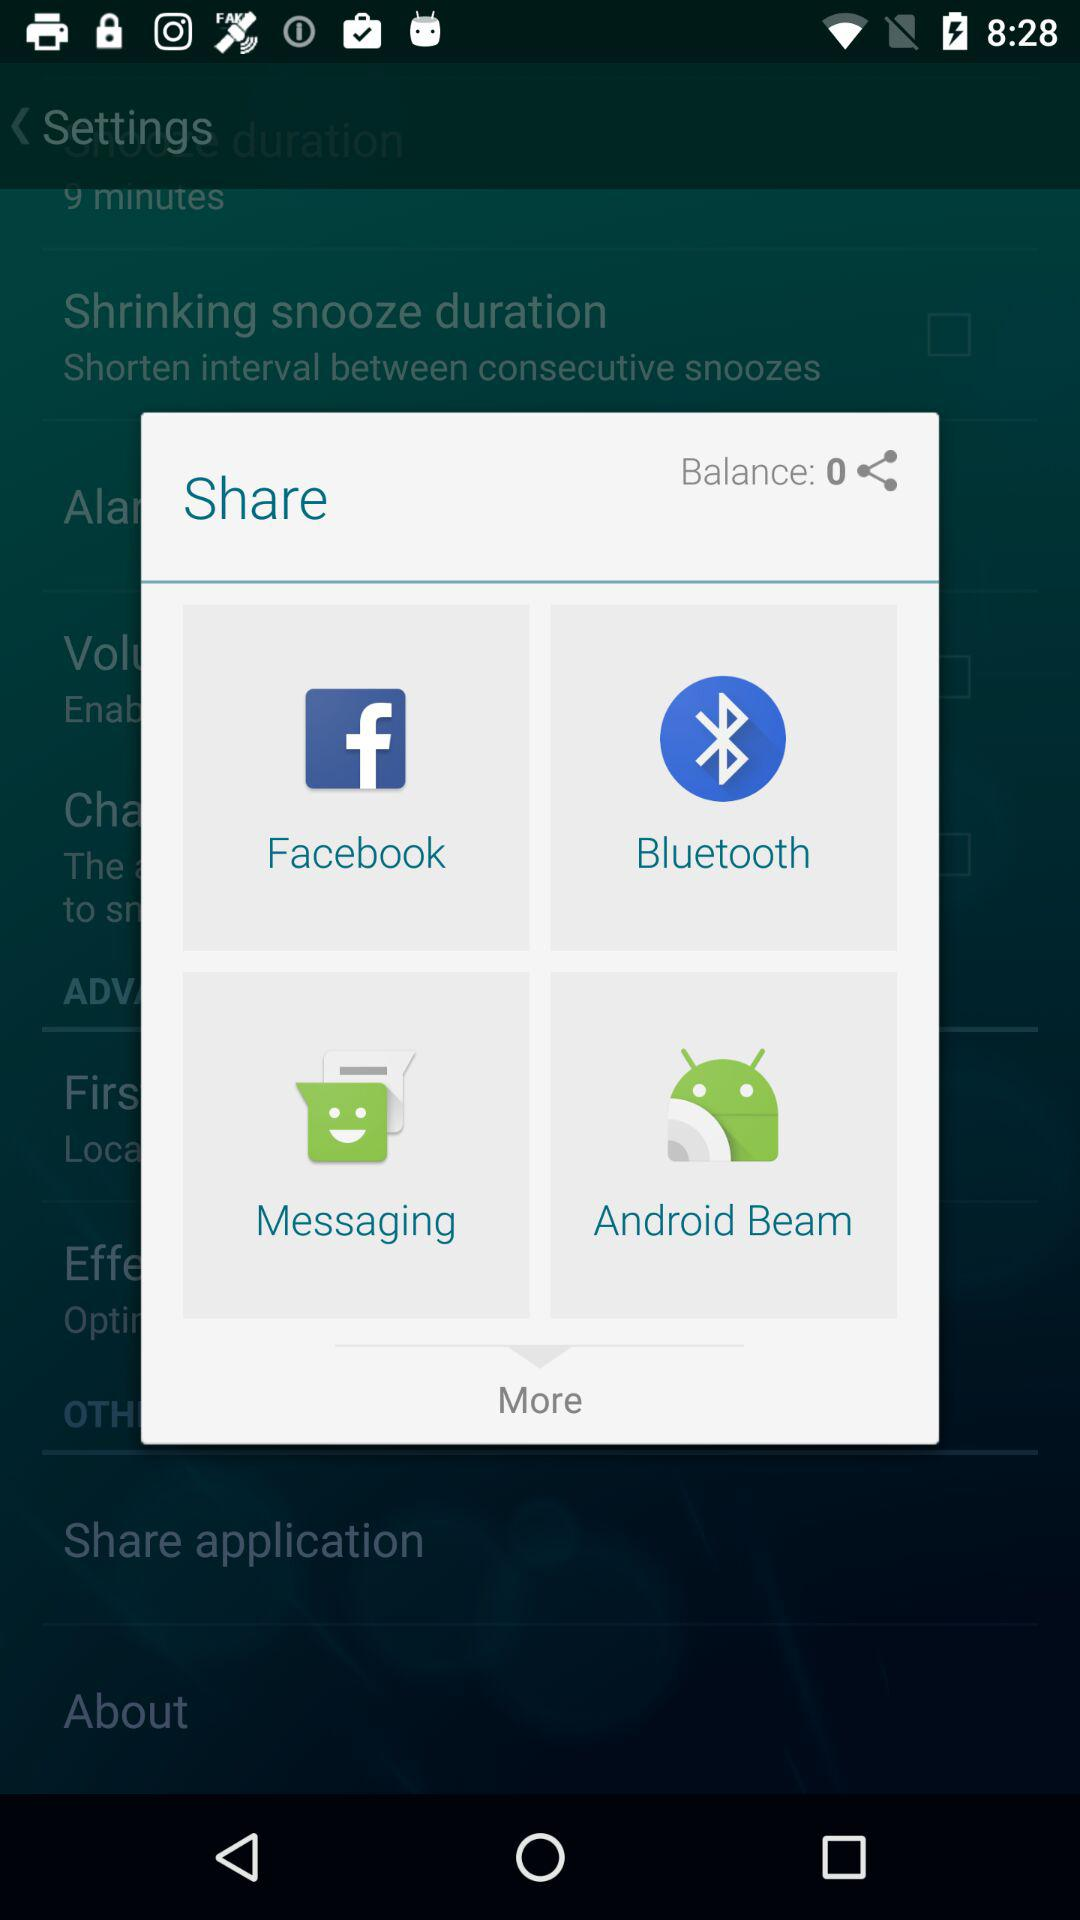What are the different mediums to share? The different mediums are "Facebook", "Bluetooth", "Messaging" and "Android Beam". 